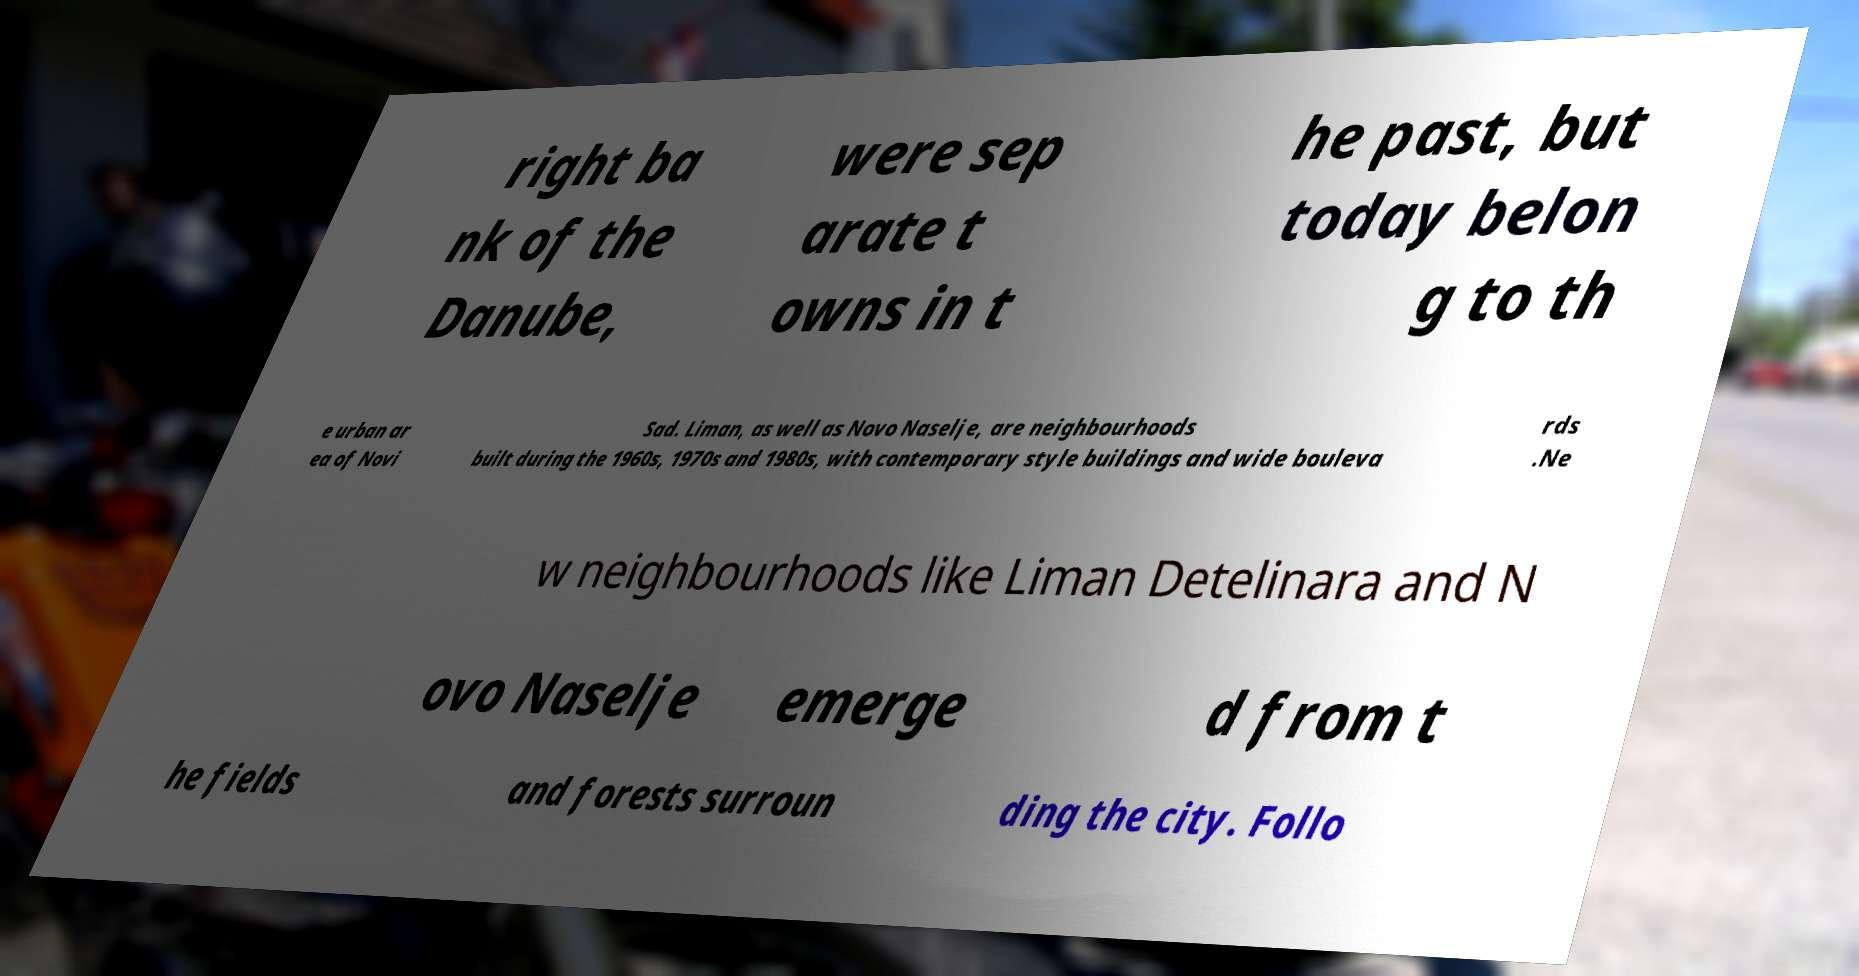Could you extract and type out the text from this image? right ba nk of the Danube, were sep arate t owns in t he past, but today belon g to th e urban ar ea of Novi Sad. Liman, as well as Novo Naselje, are neighbourhoods built during the 1960s, 1970s and 1980s, with contemporary style buildings and wide bouleva rds .Ne w neighbourhoods like Liman Detelinara and N ovo Naselje emerge d from t he fields and forests surroun ding the city. Follo 